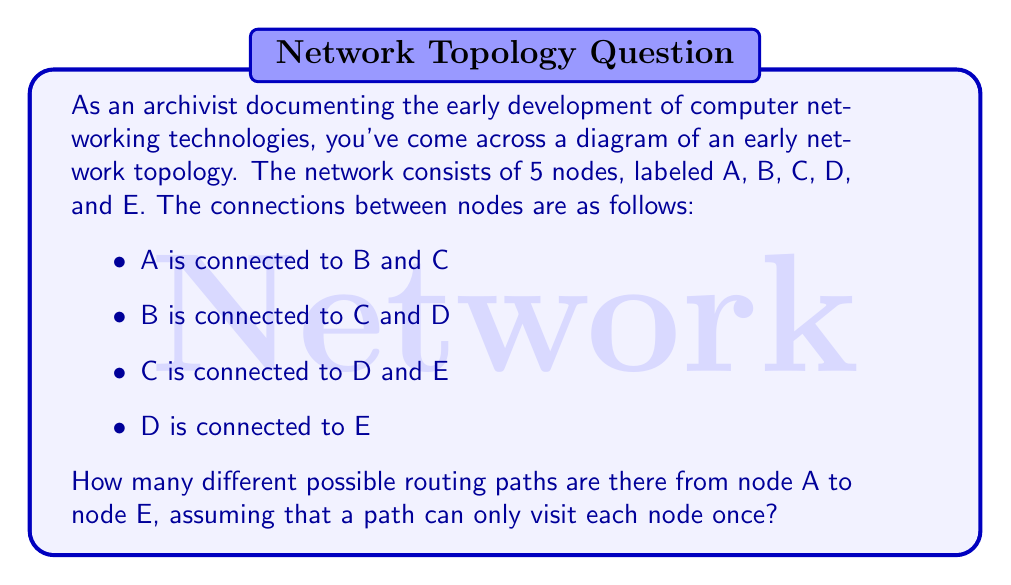Provide a solution to this math problem. To solve this problem, we can use a systematic counting approach:

1) First, let's visualize the network:

[asy]
unitsize(1cm);
pair A = (0,0), B = (2,2), C = (2,-2), D = (4,0), E = (6,0);
dot("A", A, W);
dot("B", B, NW);
dot("C", C, SW);
dot("D", D, N);
dot("E", E, E);
draw(A--B--D--E);
draw(A--C--E);
draw(B--C--D);
[/asy]

2) Now, let's count the possible paths:

   a) Paths starting A-B:
      - A-B-C-D-E
      - A-B-C-E
      - A-B-D-C-E
      - A-B-D-E

   b) Paths starting A-C:
      - A-C-B-D-E
      - A-C-D-E
      - A-C-E

3) We can verify that these are all possible paths:
   - All paths start at A and end at E
   - No node is visited more than once in any path
   - All possible connections are utilized

4) Counting the total number of paths:
   $$\text{Total paths} = \text{Paths starting A-B} + \text{Paths starting A-C}$$
   $$\text{Total paths} = 4 + 3 = 7$$

Therefore, there are 7 different possible routing paths from node A to node E in this network topology.
Answer: 7 paths 